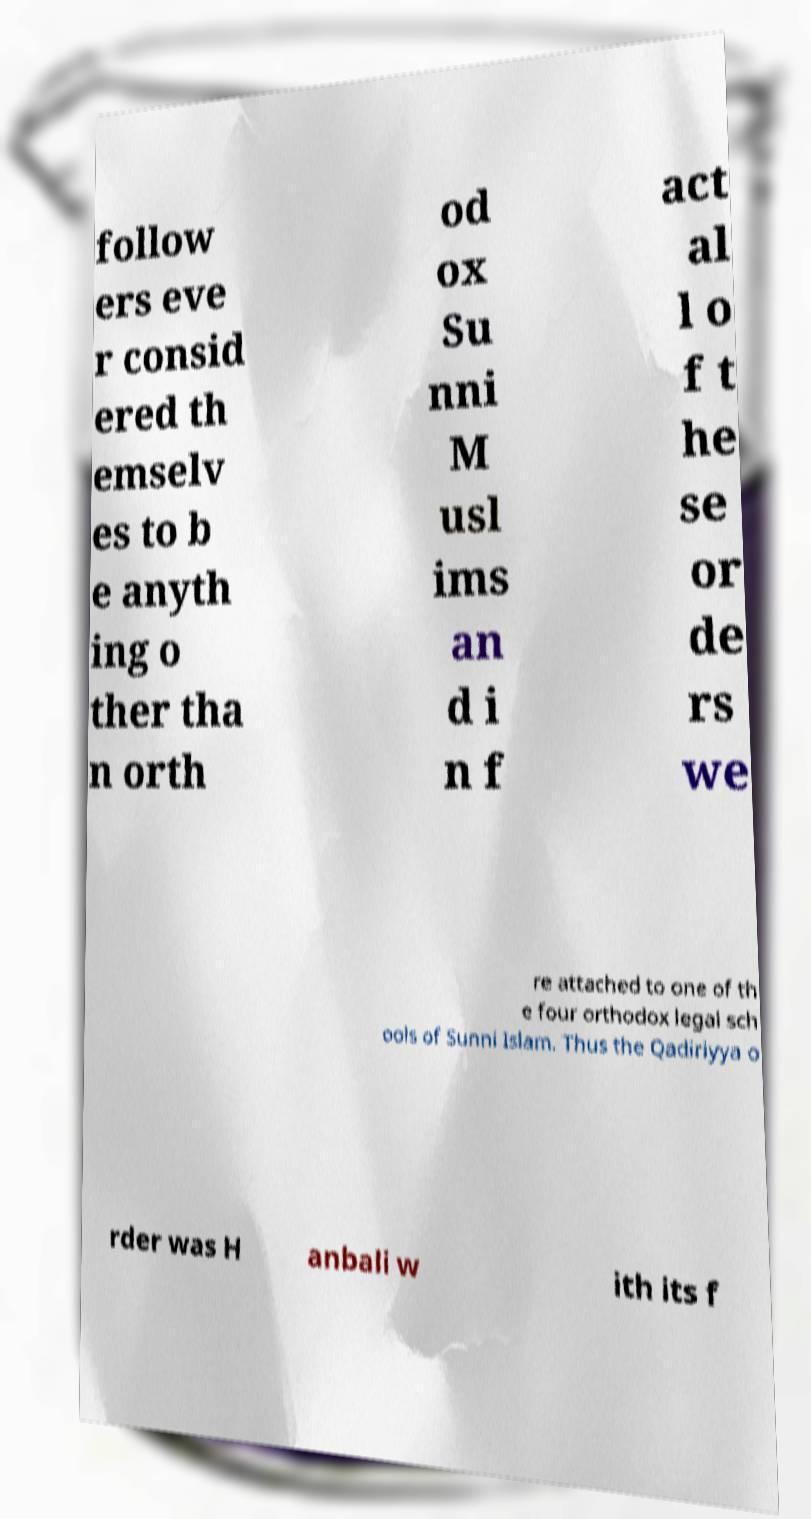What messages or text are displayed in this image? I need them in a readable, typed format. follow ers eve r consid ered th emselv es to b e anyth ing o ther tha n orth od ox Su nni M usl ims an d i n f act al l o f t he se or de rs we re attached to one of th e four orthodox legal sch ools of Sunni Islam. Thus the Qadiriyya o rder was H anbali w ith its f 